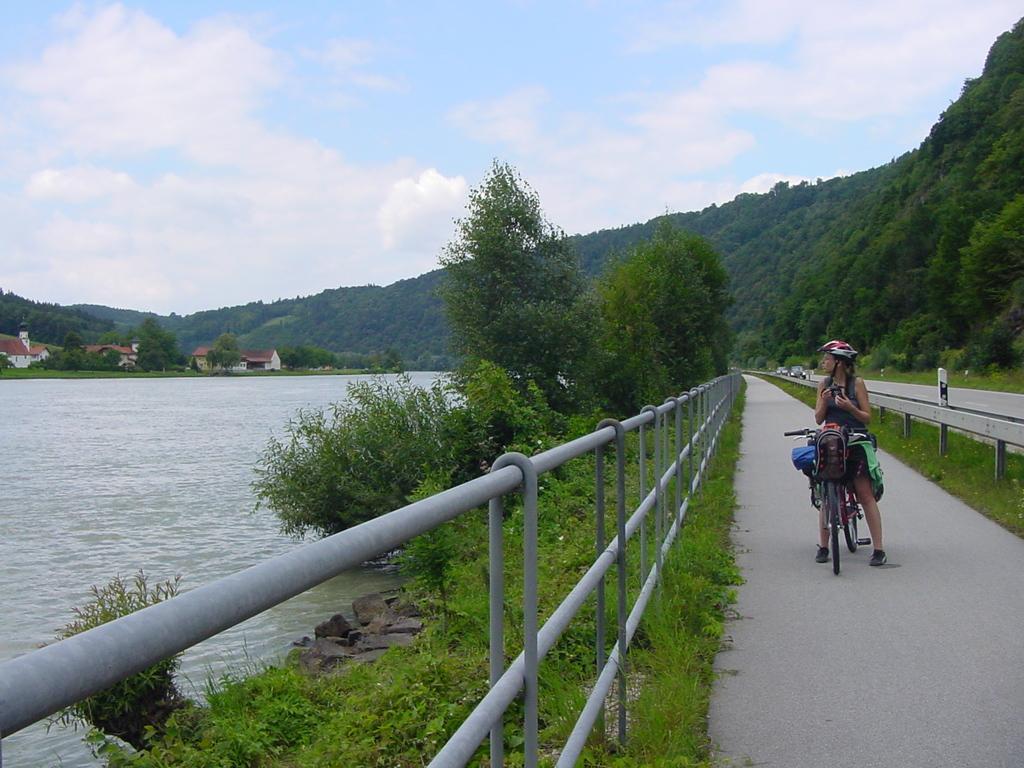Describe this image in one or two sentences. In this picture we can see a person wearing a helmet and a few things on the path. We can see vehicles, some fencing, water, grass, plants, trees, houses, other objects and the cloudy sky. 